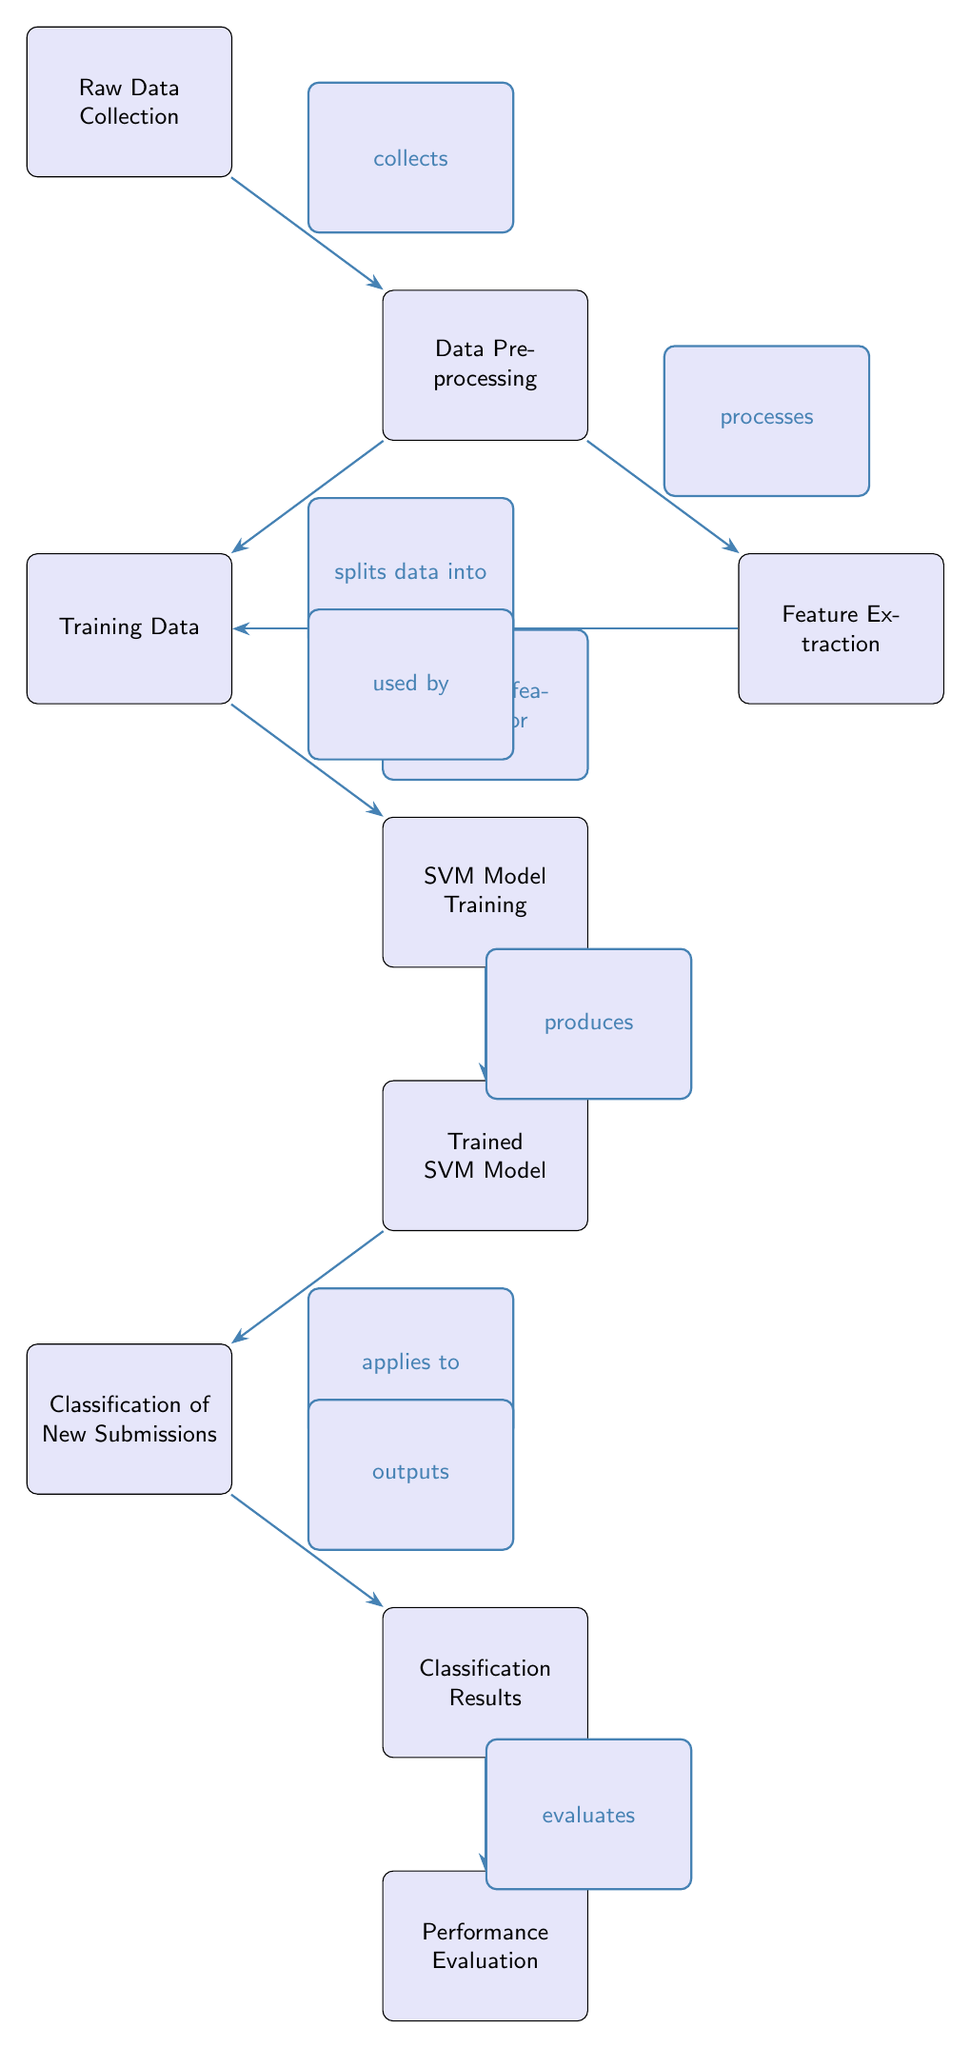What is the first step in the diagram? The diagram starts with the node labeled "Raw Data Collection," which indicates that this is the initial step in the process.
Answer: Raw Data Collection How many nodes are in the diagram? By counting the distinct labeled nodes in the diagram, we find there are nine nodes connected by edges, each representing a part of the process.
Answer: Nine What does "Data Preprocessing" do? "Data Preprocessing" processes the data and splits it into training data, as shown by the arrows pointing from it to both "Feature Extraction" and "Training Data."
Answer: Processes Which node outputs the classification results? The classification results are outputted by the node labeled "Classification Results," which is the final output of the classification process.
Answer: Classification Results How does "Feature Extraction" relate to "Training Data"? "Feature Extraction" provides features for "Training Data," as indicated by the edge connecting the two nodes with the label "provides features for."
Answer: Provides features for What is the purpose of the "Performance Evaluation" node? "Performance Evaluation" evaluates the classification results, as shown by the edge labeled "evaluates" connecting it to "Classification Results."
Answer: Evaluates Which node generates the trained SVM model? The node labeled "SVM Model Training" produces the "Trained SVM Model," as indicated by the arrow pointing from it to that node.
Answer: Produces In what step is new submissions classified? New submissions are classified in the "Classification of New Submissions" step, which follows the "Trained SVM Model" node according to the flow of the diagram.
Answer: Classification of New Submissions What does the "Trained SVM Model" apply to? The "Trained SVM Model" applies to the "Classification of New Submissions," as indicated by the directed edge from the model to that node.
Answer: Classification of New Submissions 